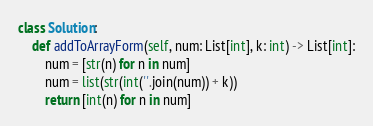<code> <loc_0><loc_0><loc_500><loc_500><_Python_>class Solution:
    def addToArrayForm(self, num: List[int], k: int) -> List[int]:
        num = [str(n) for n in num]
        num = list(str(int(''.join(num)) + k))
        return [int(n) for n in num]</code> 